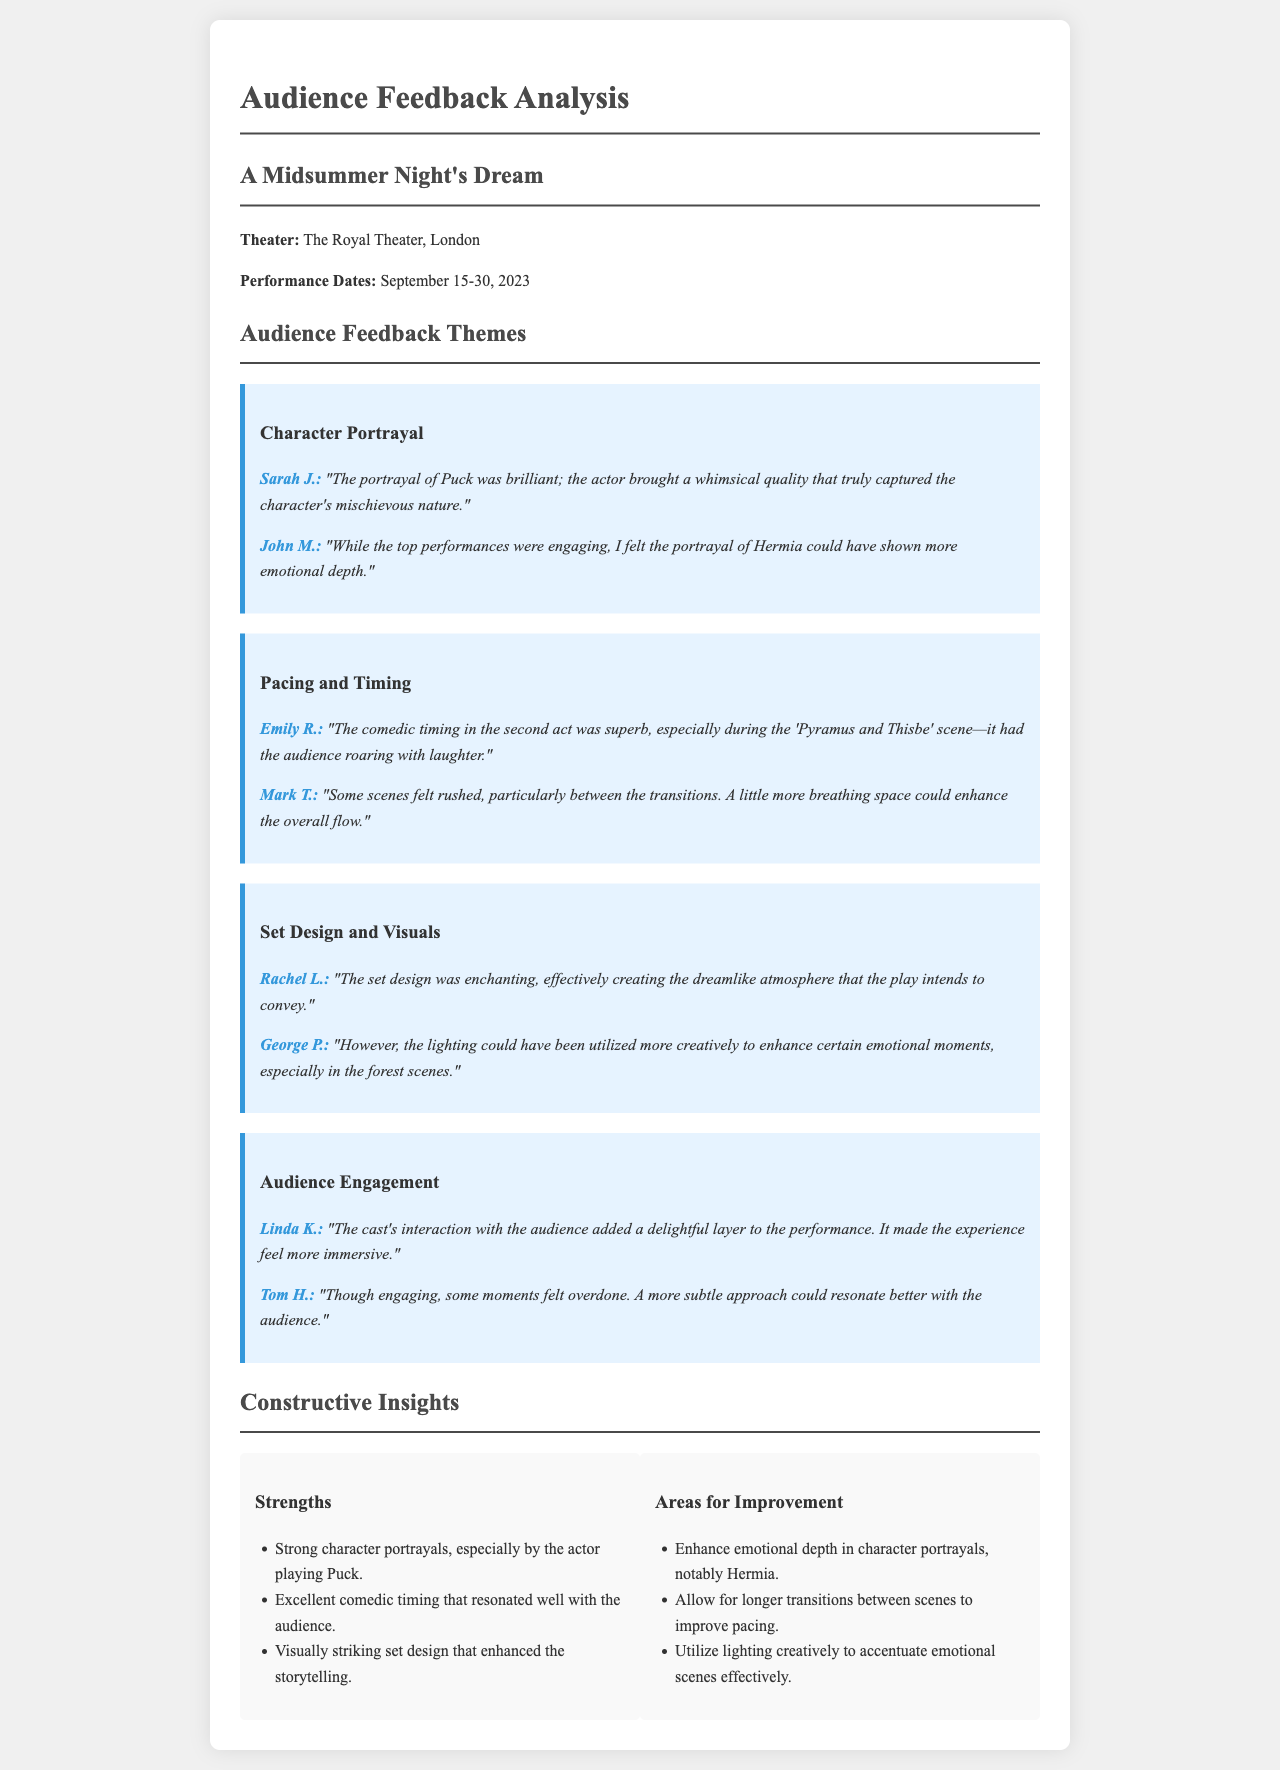What is the title of the theater production analyzed? The title of the theater production is mentioned at the beginning of the document and indicates the work being analyzed.
Answer: A Midsummer Night's Dream What was the performance date range? The performance dates can be found in the section detailing the production's schedule.
Answer: September 15-30, 2023 What character's portrayal received specific praise? Feedback from audience members highlights the actor's portrayal of a particular character as outstanding.
Answer: Puck Which scene was noted for its excellent comedic timing? The audience comment specifically references a scene known for its humor, illustrating an example of effective performance.
Answer: Pyramus and Thisbe What aspect of the set design was emphasized by the audience? Audience feedback mentions an emotional quality attributed to a particular feature of the set design.
Answer: Enchanting What was suggested as an area for improvement regarding character portrayal? One of the constructive insights points out a specific character that would benefit from deeper emotional performance.
Answer: Hermia How did the audience react to the cast's interaction with them? The audience member's comment reflects a positive experience regarding the performance's engagement with the audience.
Answer: Delightful layer What does the feedback suggest about scene transitions? A comment indicates a suggestion for adjustment concerning the flow of the performance between scenes.
Answer: Longer transitions What was a creative shortcoming mentioned in the feedback? One audience member pointed out a specific element of the production that could have been enhanced.
Answer: Lighting 